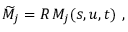<formula> <loc_0><loc_0><loc_500><loc_500>\widetilde { M } _ { j } = R \, M _ { j } ( s , u , t ) ,</formula> 